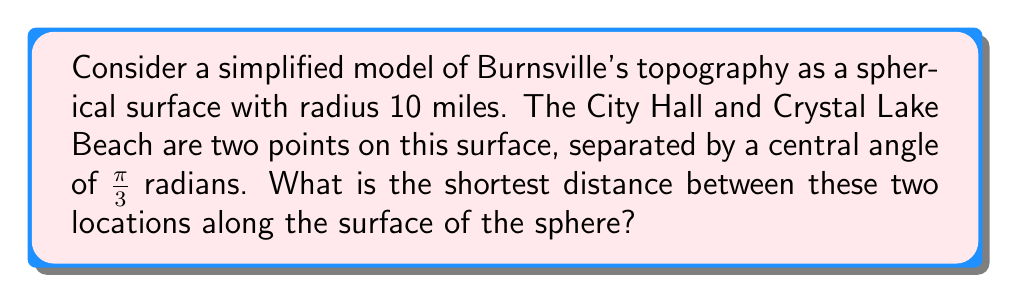Could you help me with this problem? To solve this problem, we'll use the formula for the great circle distance on a sphere:

1) The formula for the arc length $s$ on a sphere is:
   $$s = r\theta$$
   where $r$ is the radius of the sphere and $\theta$ is the central angle in radians.

2) We are given:
   - Radius $r = 10$ miles
   - Central angle $\theta = \frac{\pi}{3}$ radians

3) Substituting these values into the formula:
   $$s = 10 \cdot \frac{\pi}{3}$$

4) Simplifying:
   $$s = \frac{10\pi}{3} \approx 10.47 \text{ miles}$$

[asy]
import geometry;

size(200);
pair O=(0,0);
real r=5;
draw(circle(O,r));
pair A=(r,0);
pair B=rotate(60)*A;
draw(O--A,dashed);
draw(O--B,dashed);
draw(Arc(O,A,B));
label("City Hall",A,E);
label("Crystal Lake Beach",B,NE);
label("$\frac{\pi}{3}$",O,NE);
[/asy]

This curved path along the sphere's surface represents the shortest distance between the two points in our non-Euclidean model of Burnsville's topography.
Answer: $\frac{10\pi}{3}$ miles 